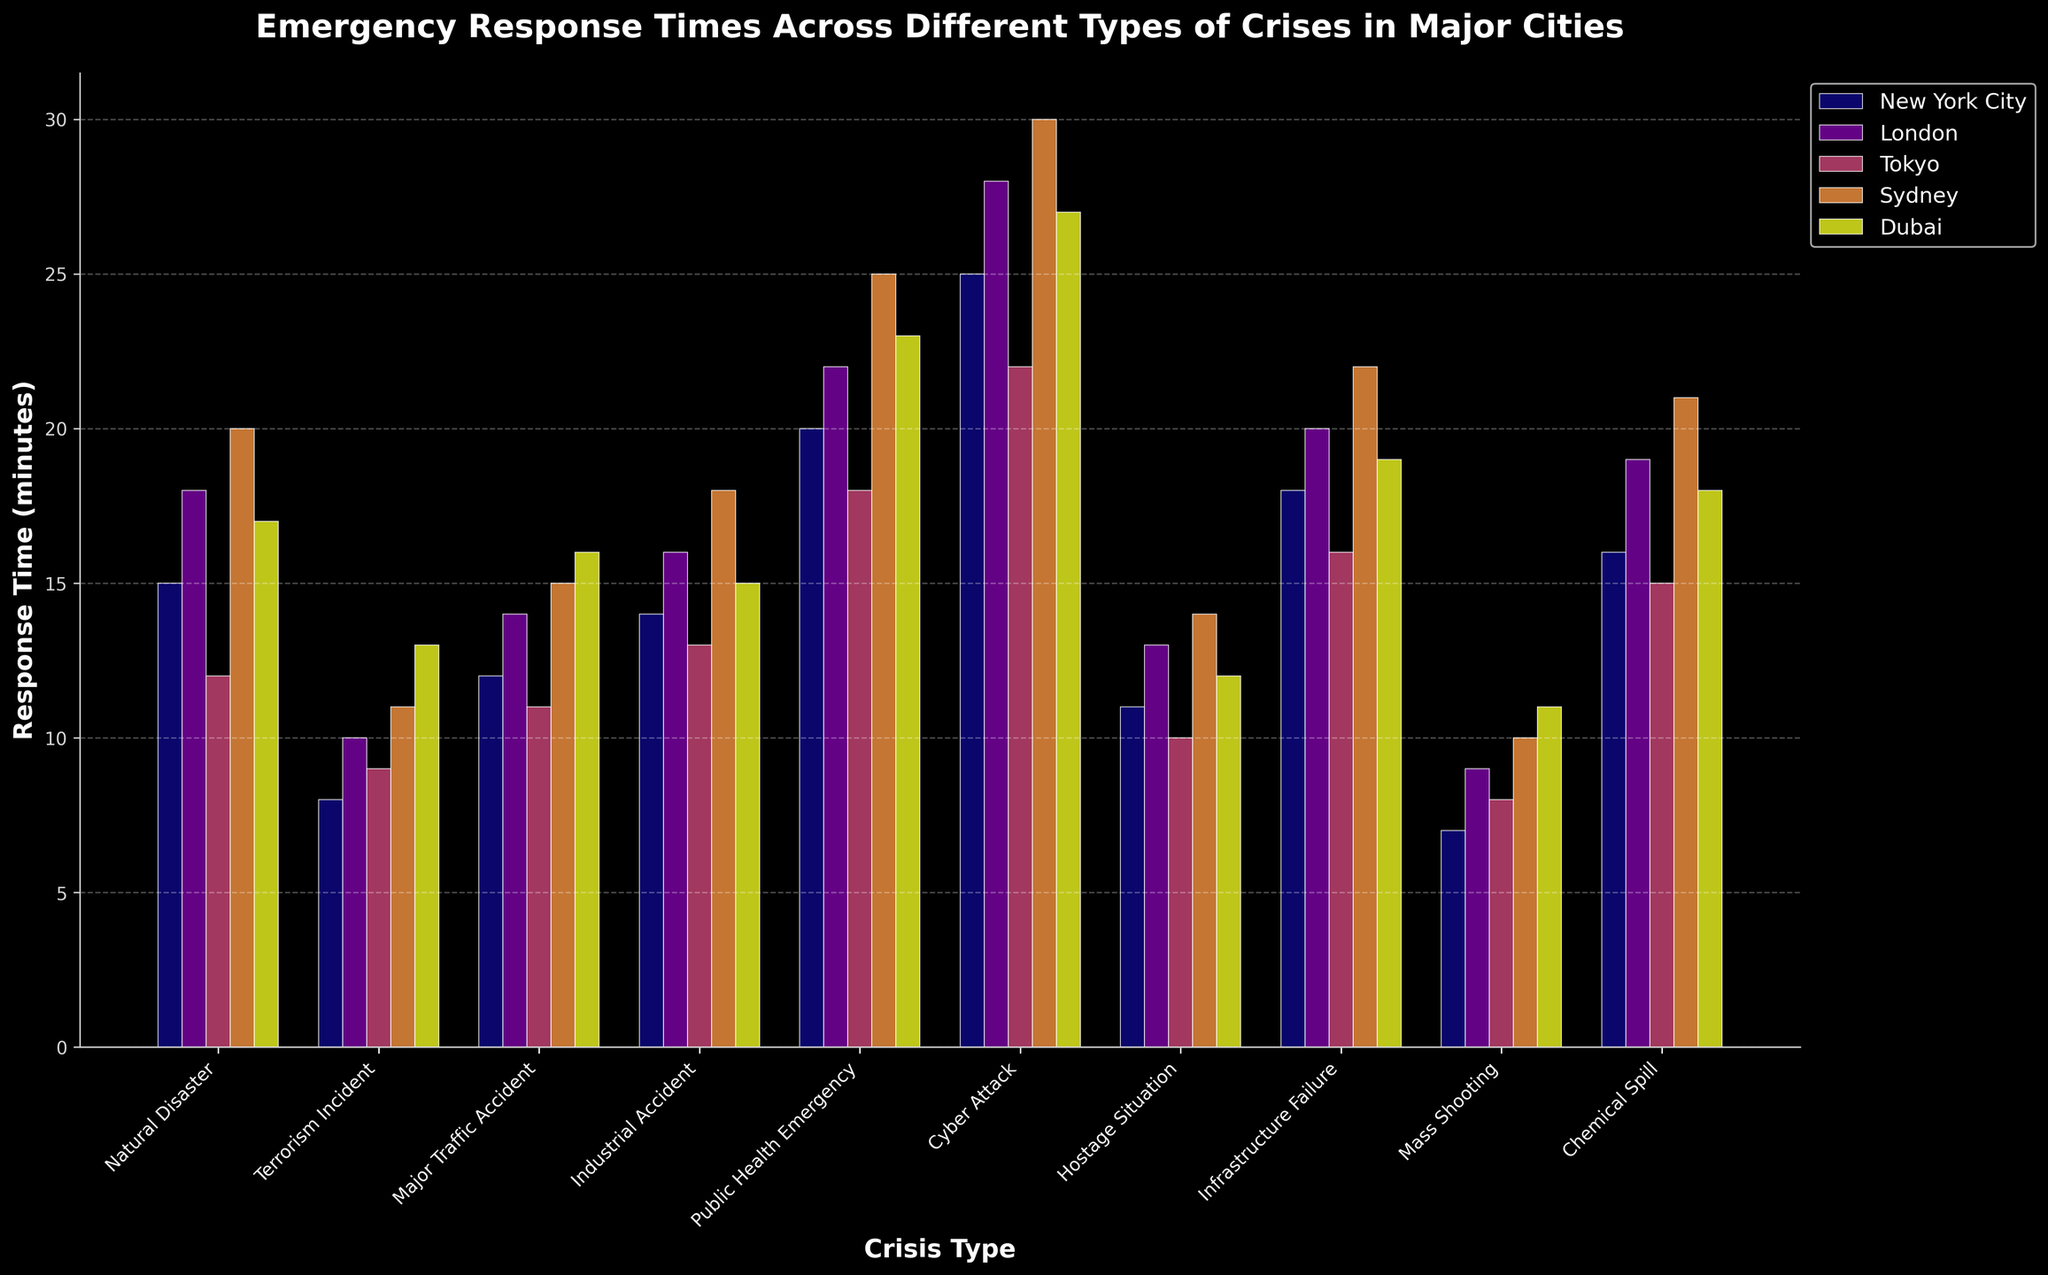What is the average response time for Natural Disasters across all five cities? Sum the response times for Natural Disasters in each city (15 + 18 + 12 + 20 + 17 = 82). Divide the total by the number of cities (82 / 5).
Answer: 16.4 Between New York City and Tokyo, which has the shorter average response time across all crisis types? Calculate the average response time for New York City and Tokyo separately: (15+8+12+14+20+25+11+18+7+16)/10 = 14.6 for NYC and (12+9+11+13+18+22+10+16+8+15)/10 = 13.4 for Tokyo. Compare the averages to see which is shorter.
Answer: Tokyo Which city has the longest response time for a Cyber Attack? Look at the tallest bar in the Cyber Attack category and identify the city it corresponds to. It is 30 minutes, which is Sydney.
Answer: Sydney What is the difference in response times for Industrial Accidents between the fastest and slowest cities? Identify the response times for Industrial Accidents across the cities (14, 16, 13, 18, 15). The fastest is Tokyo at 13 minutes and the slowest is Sydney at 18 minutes. The difference is 18 - 13.
Answer: 5 minutes Which crisis type has the highest average response time across all cities? Calculate the average response times for each crisis type and compare. The highest values are for Cyber Attack with averages: (25+28+22+30+27)/5 = 26.4, and compare with other crisis types.
Answer: Cyber Attack What is the total response time for Public Health Emergencies in New York City, Tokyo, and Sydney? Add the response times for Public Health Emergencies for the specific cities: New York City (20), Tokyo (18), and Sydney (25). Sum them up (20 + 18 + 25).
Answer: 63 minutes For Mass Shootings, which city has the quickest response time and what is it? Identify the shortest bar in the Mass Shooting category and note the city it corresponds to. The shortest bar is New York City at 7 minutes.
Answer: New York City, 7 minutes Does London or Dubai have a lower response time on average for Major Traffic Accidents and Hostage Situations combined? Calculate the combined average for each city: London (14 for Major Traffic Accident, 13 for Hostage Situation), (14+13)/2 = 13.5. Dubai (16 for Major Traffic Accident, 12 for Hostage Situation), (16+12)/2 = 14. Compare 13.5 and 14.
Answer: London Which two crisis types have similar response times in Sydney? Compare the response times for Sydney across all crisis types and find those with close values. Major Traffic Accident (15) and Industrial Accident (18), these values are relatively close.
Answer: Major Traffic Accident and Industrial Accident (15 and 18) In which city is the response time for a Terrorism Incident closest to 10 minutes? Check the Terrorism Incident response times across all cities: New York City (8), London (10), Tokyo (9), Sydney (11), Dubai (13). London exactly matches 10 minutes.
Answer: London 